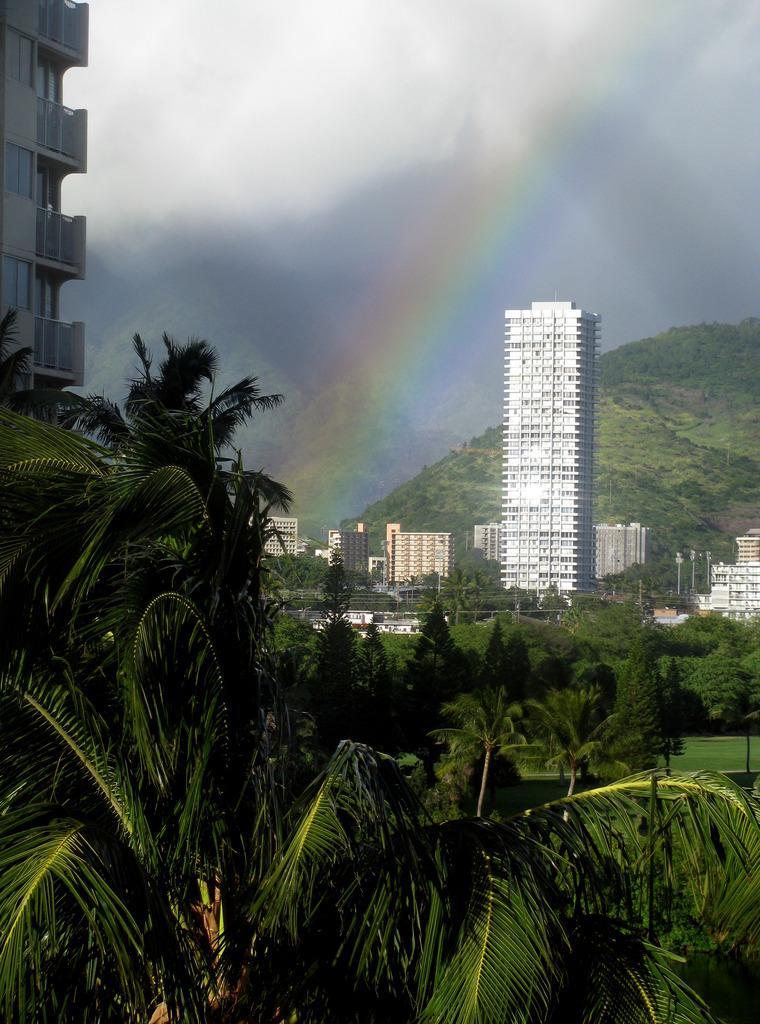Please provide a concise description of this image. In this image I can see few trees in green color, buildings. In the background I can see the rainbow and the sky is in white and gray color. 